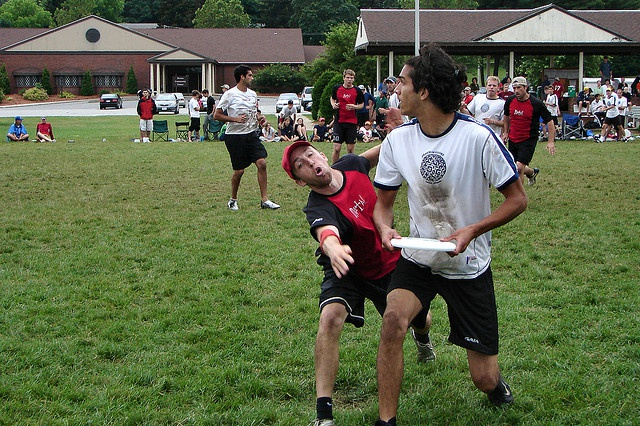Describe the objects in this image and their specific colors. I can see people in black, darkgray, lavender, and gray tones, people in black, maroon, gray, and brown tones, people in black, lightgray, gray, and darkgray tones, people in black, white, darkgray, and gray tones, and people in black, maroon, brown, and gray tones in this image. 